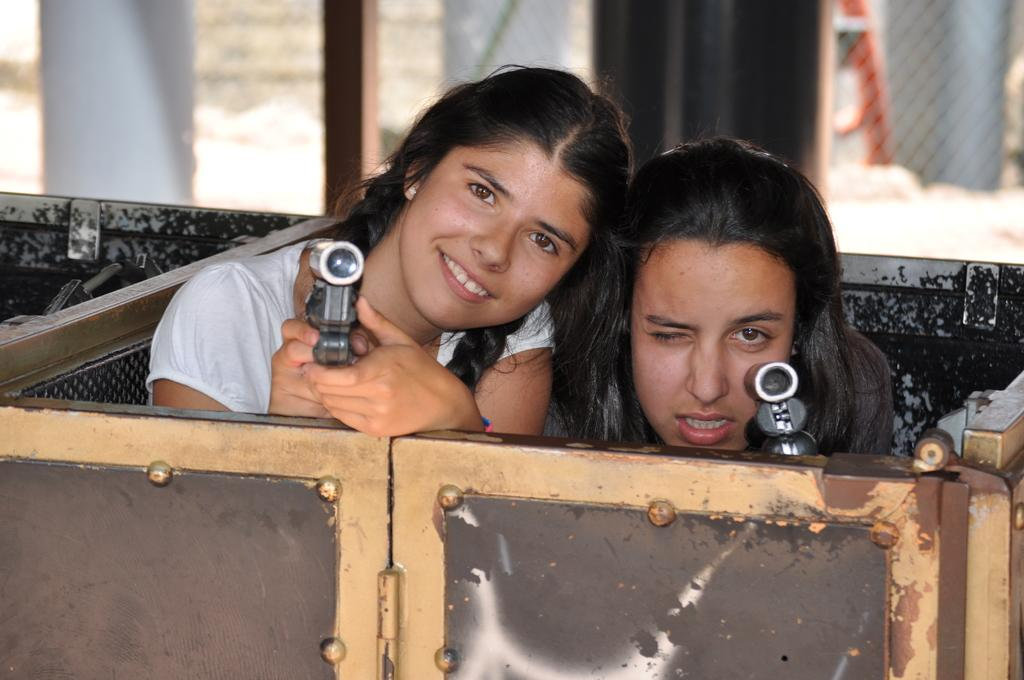How many women are in the image? There are two women in the image. What is the setting of the image? The women are inside a container with a door. What are the women holding in their hands? The women are holding objects in their hands. What can be seen in the background of the image? There are poles, a fence, and a building in the background of the image. What type of home does the achiever live in, as seen in the image? There is no mention of a home or an achiever in the image. The image features two women inside a container with a door, holding objects in their hands, and surrounded by a background with poles, a fence, and a building. 